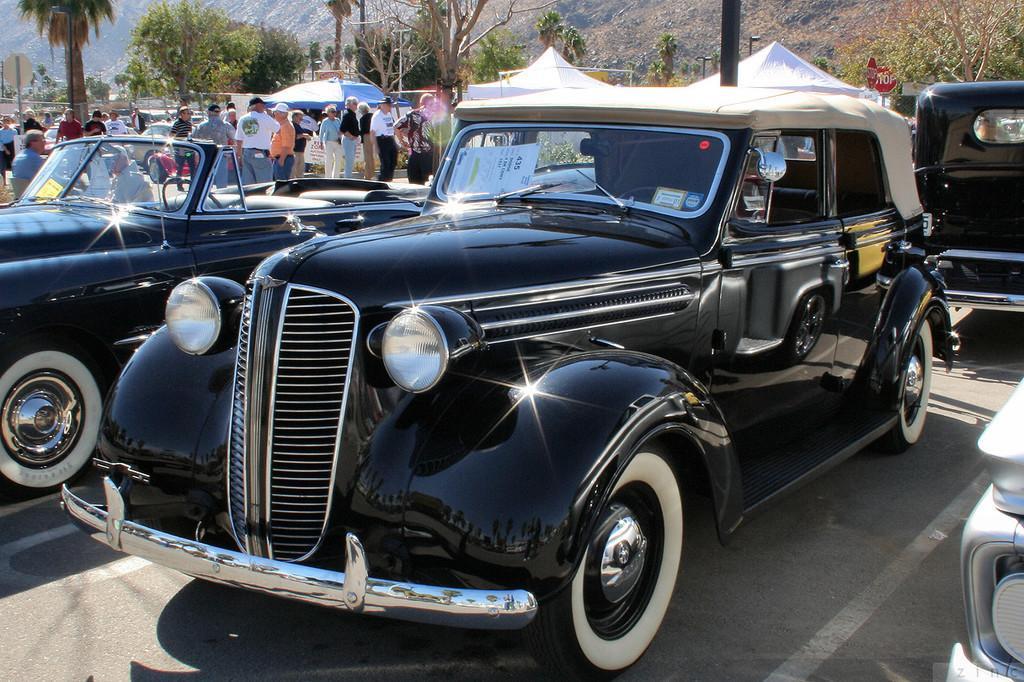Describe this image in one or two sentences. In this picture there are vehicles and there are group of people and there is a tent and there are trees and poles and there is a mountain. At the bottom there is a road. 